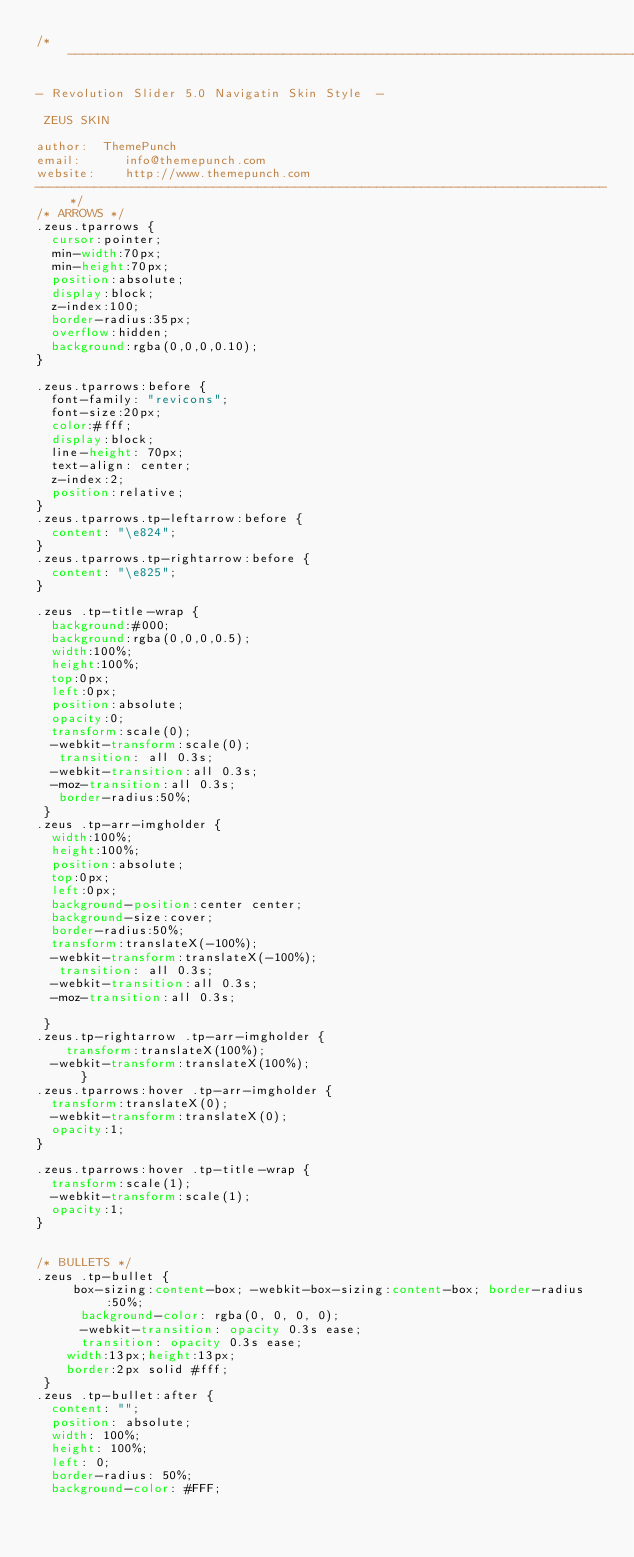Convert code to text. <code><loc_0><loc_0><loc_500><loc_500><_CSS_>/*-----------------------------------------------------------------------------

- Revolution Slider 5.0 Navigatin Skin Style  -

 ZEUS SKIN

author:  ThemePunch
email:      info@themepunch.com
website:    http://www.themepunch.com
-----------------------------------------------------------------------------*/
/* ARROWS */
.zeus.tparrows {
  cursor:pointer;
  min-width:70px;
  min-height:70px;
  position:absolute;
  display:block;
  z-index:100;
  border-radius:35px;   
  overflow:hidden;
  background:rgba(0,0,0,0.10);
}

.zeus.tparrows:before {
  font-family: "revicons";
  font-size:20px;
  color:#fff;
  display:block;
  line-height: 70px;
  text-align: center;    
  z-index:2;
  position:relative;
}
.zeus.tparrows.tp-leftarrow:before {
  content: "\e824";
}
.zeus.tparrows.tp-rightarrow:before {
  content: "\e825";
}

.zeus .tp-title-wrap {
  background:#000;
  background:rgba(0,0,0,0.5);
  width:100%;
  height:100%;
  top:0px;
  left:0px;
  position:absolute;
  opacity:0;
  transform:scale(0);
  -webkit-transform:scale(0);
   transition: all 0.3s;
  -webkit-transition:all 0.3s;
  -moz-transition:all 0.3s;
   border-radius:50%;
 }
.zeus .tp-arr-imgholder {
  width:100%;
  height:100%;
  position:absolute;
  top:0px;
  left:0px;
  background-position:center center;
  background-size:cover;
  border-radius:50%;
  transform:translateX(-100%);
  -webkit-transform:translateX(-100%);
   transition: all 0.3s;
  -webkit-transition:all 0.3s;
  -moz-transition:all 0.3s;

 }
.zeus.tp-rightarrow .tp-arr-imgholder {
    transform:translateX(100%);
  -webkit-transform:translateX(100%);
      }
.zeus.tparrows:hover .tp-arr-imgholder {
  transform:translateX(0);
  -webkit-transform:translateX(0);
  opacity:1;
}
      
.zeus.tparrows:hover .tp-title-wrap {
  transform:scale(1);
  -webkit-transform:scale(1);
  opacity:1;
}
 

/* BULLETS */
.zeus .tp-bullet {
     box-sizing:content-box; -webkit-box-sizing:content-box; border-radius:50%;
      background-color: rgba(0, 0, 0, 0);
      -webkit-transition: opacity 0.3s ease;
      transition: opacity 0.3s ease;
	  width:13px;height:13px;
	  border:2px solid #fff;
 }
.zeus .tp-bullet:after {
  content: "";
  position: absolute;
  width: 100%;
  height: 100%;
  left: 0;
  border-radius: 50%;
  background-color: #FFF;</code> 